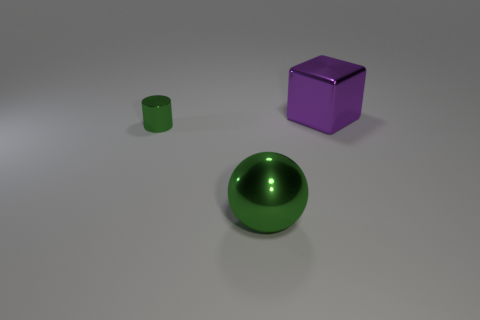Add 3 tiny gray cubes. How many objects exist? 6 Subtract all cylinders. How many objects are left? 2 Subtract 0 green blocks. How many objects are left? 3 Subtract all big brown metal balls. Subtract all green shiny balls. How many objects are left? 2 Add 1 green things. How many green things are left? 3 Add 1 tiny cyan metallic balls. How many tiny cyan metallic balls exist? 1 